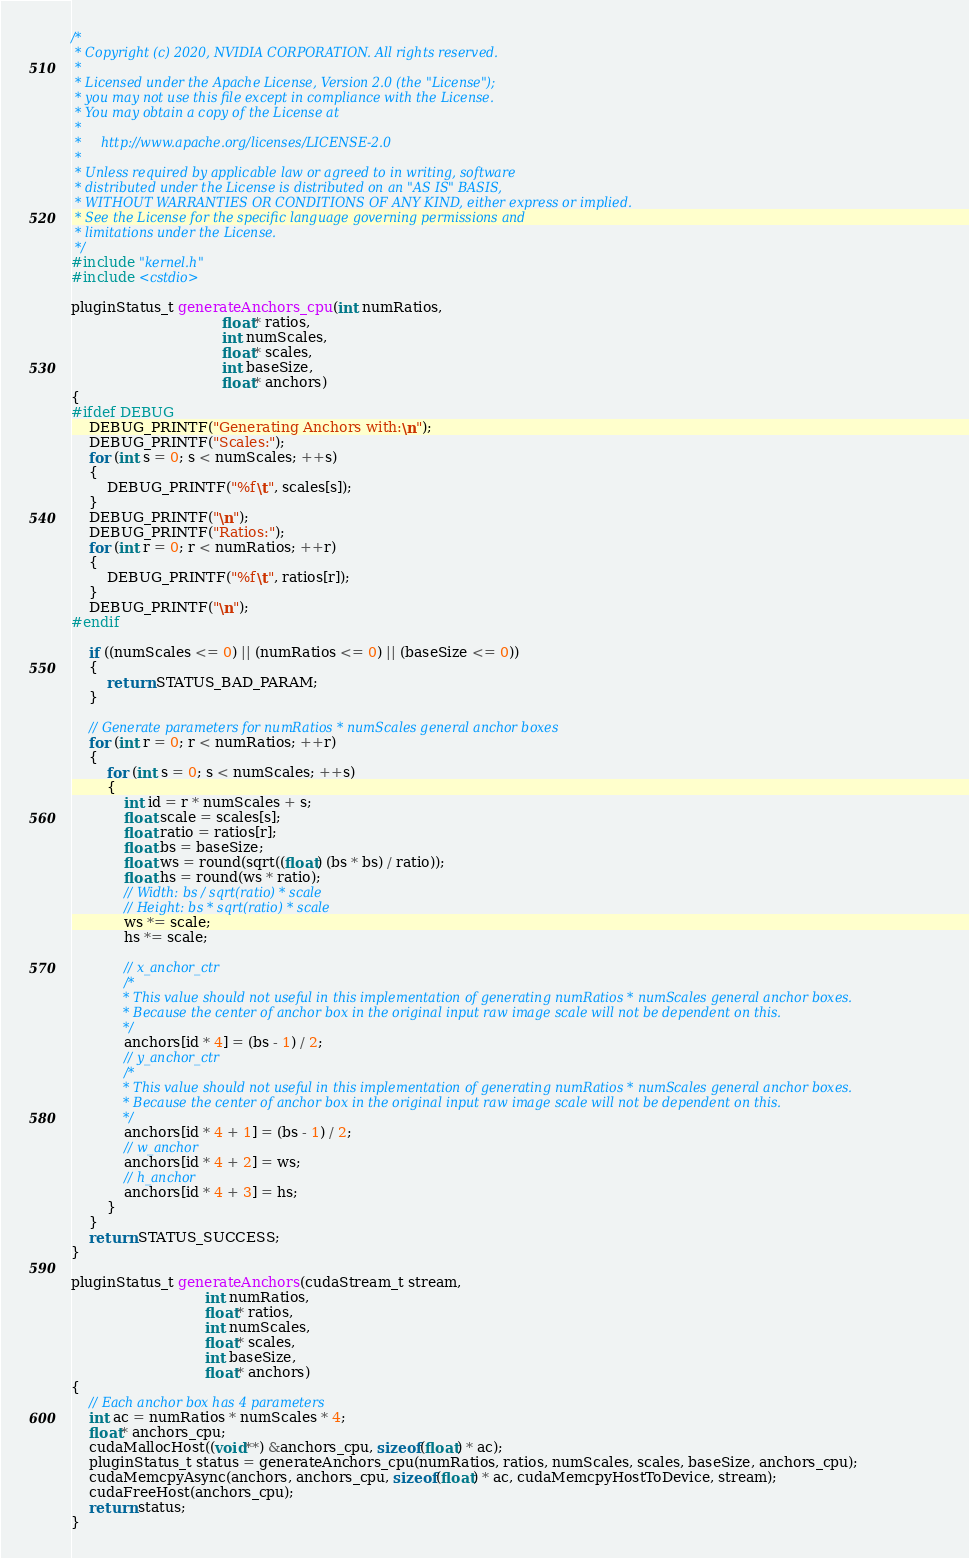Convert code to text. <code><loc_0><loc_0><loc_500><loc_500><_Cuda_>/*
 * Copyright (c) 2020, NVIDIA CORPORATION. All rights reserved.
 *
 * Licensed under the Apache License, Version 2.0 (the "License");
 * you may not use this file except in compliance with the License.
 * You may obtain a copy of the License at
 *
 *     http://www.apache.org/licenses/LICENSE-2.0
 *
 * Unless required by applicable law or agreed to in writing, software
 * distributed under the License is distributed on an "AS IS" BASIS,
 * WITHOUT WARRANTIES OR CONDITIONS OF ANY KIND, either express or implied.
 * See the License for the specific language governing permissions and
 * limitations under the License.
 */
#include "kernel.h"
#include <cstdio>

pluginStatus_t generateAnchors_cpu(int numRatios,
                                  float* ratios,
                                  int numScales,
                                  float* scales,
                                  int baseSize,
                                  float* anchors)
{
#ifdef DEBUG
    DEBUG_PRINTF("Generating Anchors with:\n");
    DEBUG_PRINTF("Scales:");
    for (int s = 0; s < numScales; ++s)
    {
        DEBUG_PRINTF("%f\t", scales[s]);
    }
    DEBUG_PRINTF("\n");
    DEBUG_PRINTF("Ratios:");
    for (int r = 0; r < numRatios; ++r)
    {
        DEBUG_PRINTF("%f\t", ratios[r]);
    }
    DEBUG_PRINTF("\n");
#endif

    if ((numScales <= 0) || (numRatios <= 0) || (baseSize <= 0))
    {
        return STATUS_BAD_PARAM;
    }

    // Generate parameters for numRatios * numScales general anchor boxes
    for (int r = 0; r < numRatios; ++r)
    {
        for (int s = 0; s < numScales; ++s)
        {
            int id = r * numScales + s;
            float scale = scales[s];
            float ratio = ratios[r];
            float bs = baseSize;
            float ws = round(sqrt((float) (bs * bs) / ratio));
            float hs = round(ws * ratio);
            // Width: bs / sqrt(ratio) * scale
            // Height: bs * sqrt(ratio) * scale
            ws *= scale;
            hs *= scale;

            // x_anchor_ctr
            /*
             * This value should not useful in this implementation of generating numRatios * numScales general anchor boxes.
             * Because the center of anchor box in the original input raw image scale will not be dependent on this. 
             */
            anchors[id * 4] = (bs - 1) / 2;
            // y_anchor_ctr
            /*
             * This value should not useful in this implementation of generating numRatios * numScales general anchor boxes.
             * Because the center of anchor box in the original input raw image scale will not be dependent on this. 
             */
            anchors[id * 4 + 1] = (bs - 1) / 2;
            // w_anchor
            anchors[id * 4 + 2] = ws;
            // h_anchor
            anchors[id * 4 + 3] = hs;
        }
    }
    return STATUS_SUCCESS;
}

pluginStatus_t generateAnchors(cudaStream_t stream,
                              int numRatios,
                              float* ratios,
                              int numScales,
                              float* scales,
                              int baseSize,
                              float* anchors)
{
    // Each anchor box has 4 parameters
    int ac = numRatios * numScales * 4;
    float* anchors_cpu;
    cudaMallocHost((void**) &anchors_cpu, sizeof(float) * ac);
    pluginStatus_t status = generateAnchors_cpu(numRatios, ratios, numScales, scales, baseSize, anchors_cpu);
    cudaMemcpyAsync(anchors, anchors_cpu, sizeof(float) * ac, cudaMemcpyHostToDevice, stream);
    cudaFreeHost(anchors_cpu);
    return status;
}
</code> 